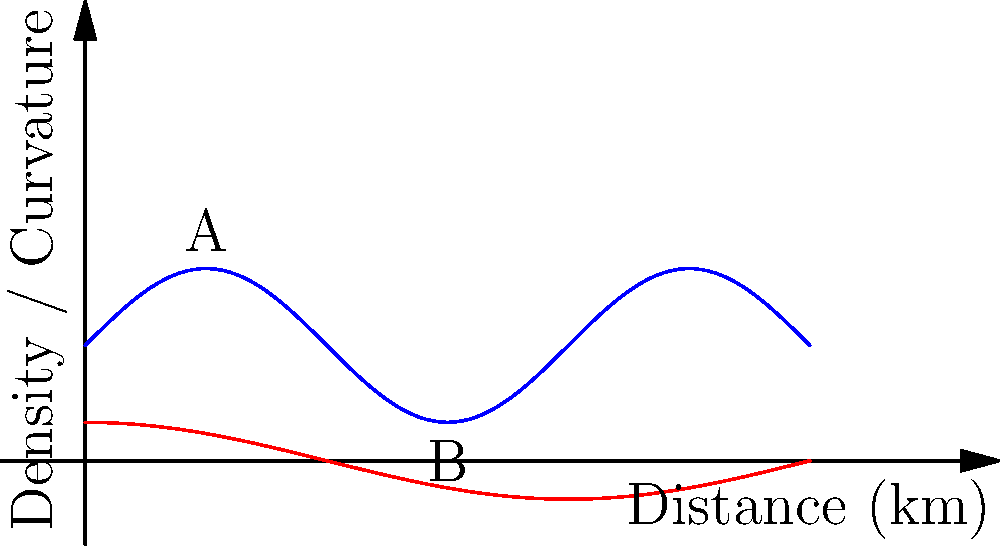During a live traffic report with Sally Boazman, you're analyzing a curved road where the traffic density (in vehicles per km) is given by the function $D(x) = 2\sin(\frac{x}{2}) + 3$, where $x$ is the distance in km along the road. The road's curvature is represented by $C(x) = \cos(\frac{x}{4})$. At what point along the road is the rate of change of traffic density with respect to distance equal to the road's curvature? To solve this problem, we need to follow these steps:

1) First, we need to find the rate of change of traffic density. This is given by the derivative of $D(x)$:

   $$D'(x) = \frac{d}{dx}(2\sin(\frac{x}{2}) + 3) = 2 \cdot \frac{1}{2}\cos(\frac{x}{2}) = \cos(\frac{x}{2})$$

2) Now, we need to find where this rate of change equals the road's curvature:

   $$D'(x) = C(x)$$
   $$\cos(\frac{x}{2}) = \cos(\frac{x}{4})$$

3) This equation is true when $\frac{x}{2} = \frac{x}{4} + 2\pi n$ or $\frac{x}{2} = -\frac{x}{4} + \pi + 2\pi n$, where $n$ is an integer.

4) From the first condition:
   $$\frac{x}{2} = \frac{x}{4} + 2\pi n$$
   $$\frac{x}{4} = 2\pi n$$
   $$x = 8\pi n$$

5) From the second condition:
   $$\frac{x}{2} = -\frac{x}{4} + \pi + 2\pi n$$
   $$\frac{3x}{4} = \pi + 2\pi n$$
   $$x = \frac{4\pi}{3} + \frac{8\pi n}{3}$$

6) The smallest positive solution is when $n=0$ in the second equation, giving $x = \frac{4\pi}{3}$ km.

Therefore, the rate of change of traffic density equals the road's curvature at a distance of $\frac{4\pi}{3}$ km along the road.
Answer: $\frac{4\pi}{3}$ km 